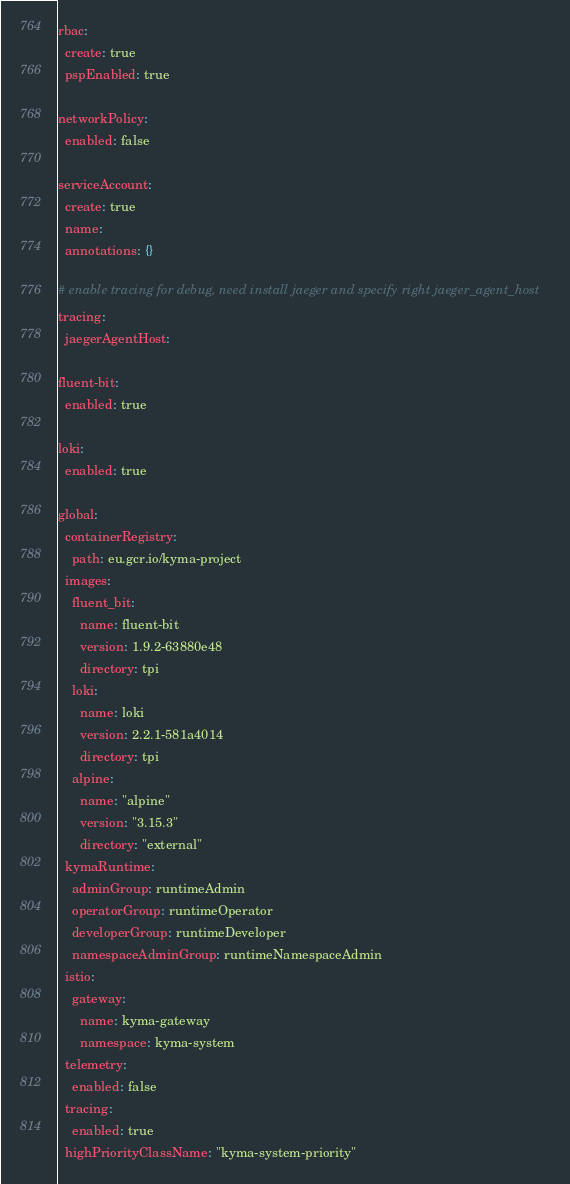Convert code to text. <code><loc_0><loc_0><loc_500><loc_500><_YAML_>rbac:
  create: true
  pspEnabled: true

networkPolicy:
  enabled: false

serviceAccount:
  create: true
  name:
  annotations: {}

# enable tracing for debug, need install jaeger and specify right jaeger_agent_host
tracing:
  jaegerAgentHost:

fluent-bit:
  enabled: true

loki:
  enabled: true

global:
  containerRegistry:
    path: eu.gcr.io/kyma-project
  images:
    fluent_bit:
      name: fluent-bit
      version: 1.9.2-63880e48
      directory: tpi
    loki:
      name: loki
      version: 2.2.1-581a4014
      directory: tpi
    alpine:
      name: "alpine"
      version: "3.15.3"
      directory: "external"
  kymaRuntime:
    adminGroup: runtimeAdmin
    operatorGroup: runtimeOperator
    developerGroup: runtimeDeveloper
    namespaceAdminGroup: runtimeNamespaceAdmin
  istio:
    gateway:
      name: kyma-gateway
      namespace: kyma-system
  telemetry:
    enabled: false
  tracing:
    enabled: true
  highPriorityClassName: "kyma-system-priority"
</code> 